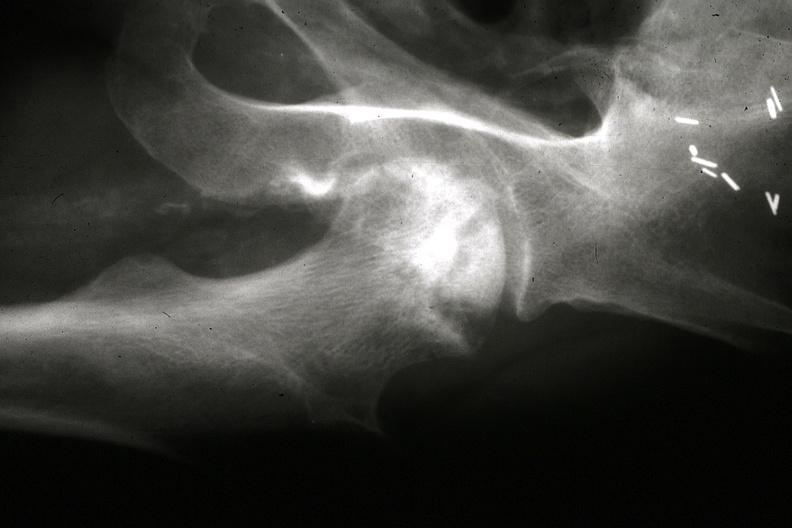how are x-ray close-up of right femoral head from pelvic x-ray and other x-rays in slides?
Answer the question using a single word or phrase. Gross 